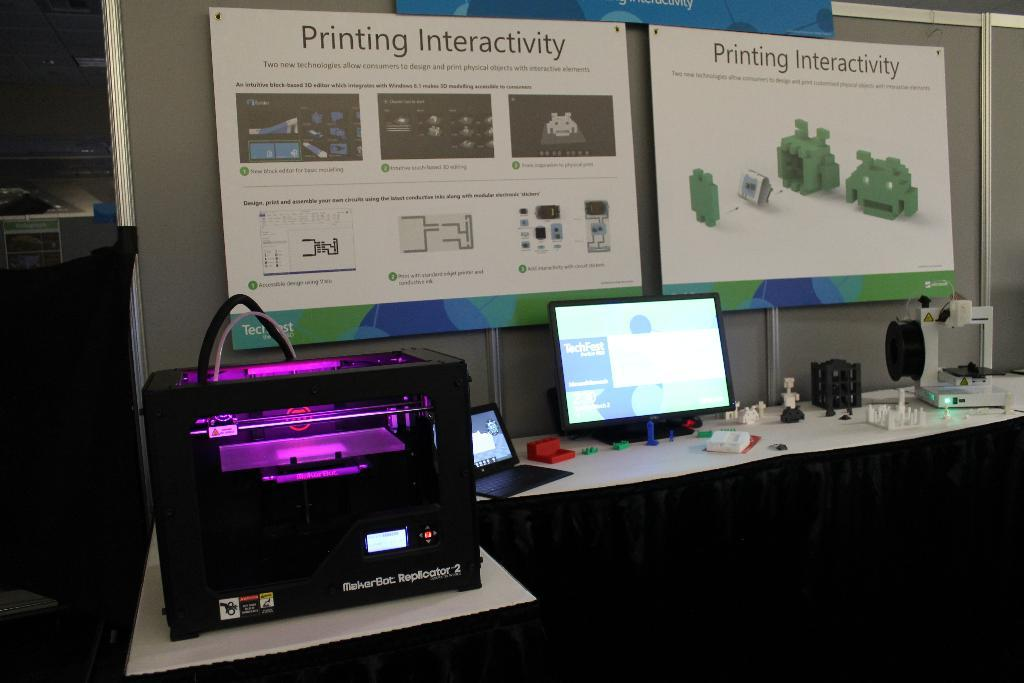<image>
Share a concise interpretation of the image provided. Two signs read "Printing Interactivity" above a computer 